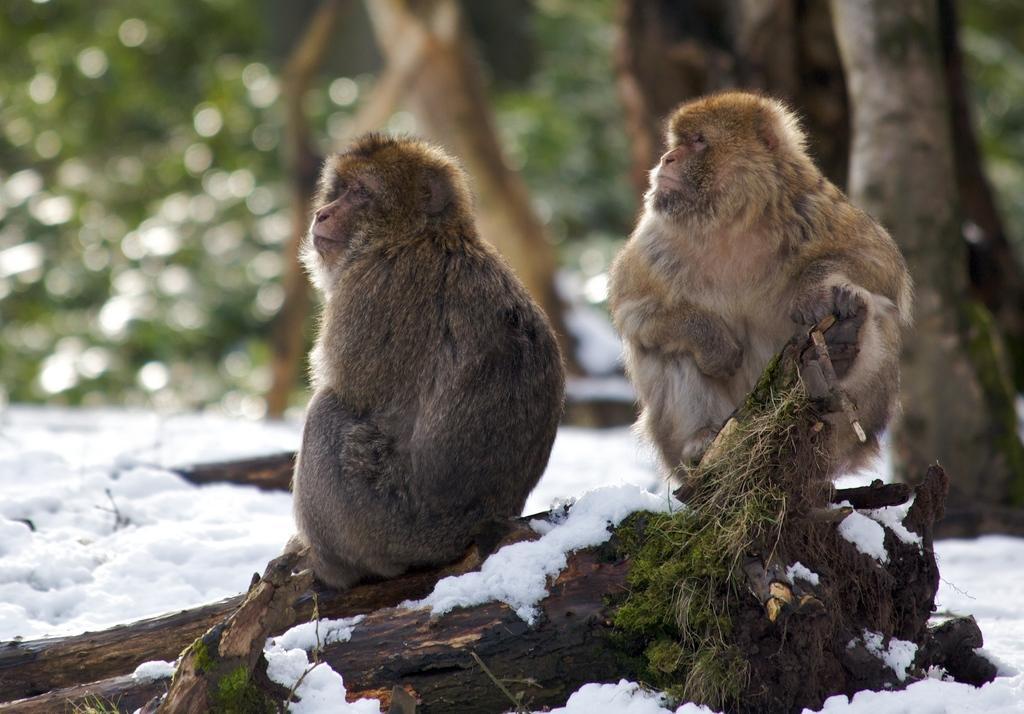Could you give a brief overview of what you see in this image? In this image I can see two monkeys are sitting on a stick which is on the ground. Here I can see the snow. In the background there are some trees. 